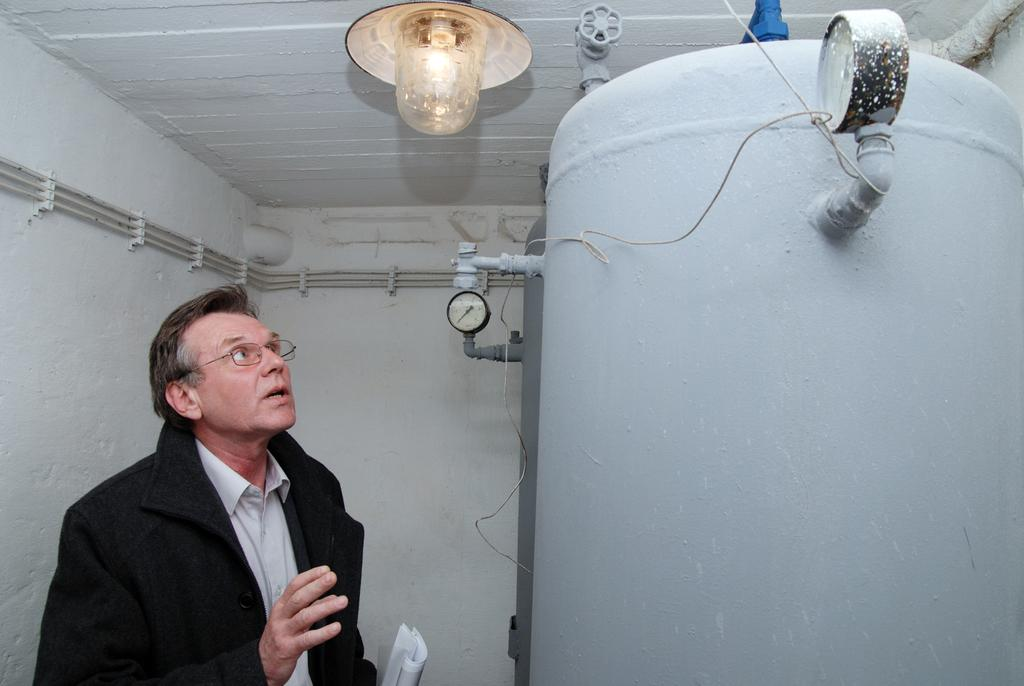Who is present in the image? There is a man in the image. What is the man wearing on his face? The man is wearing spectacles. What type of object can be seen in the image that is typically used for storing or transporting liquids? There is a cylindrical tank in the image. What type of objects are present in the image that are used for measuring or monitoring? There are meters in the image. What type of object is present in the image that produces light? There is a bulb in the image. What type of structure can be seen in the background of the image? There is a wall in the background of the image. What type of pain is the man experiencing in the image? There is no indication of pain in the image; the man is simply present and wearing spectacles. 